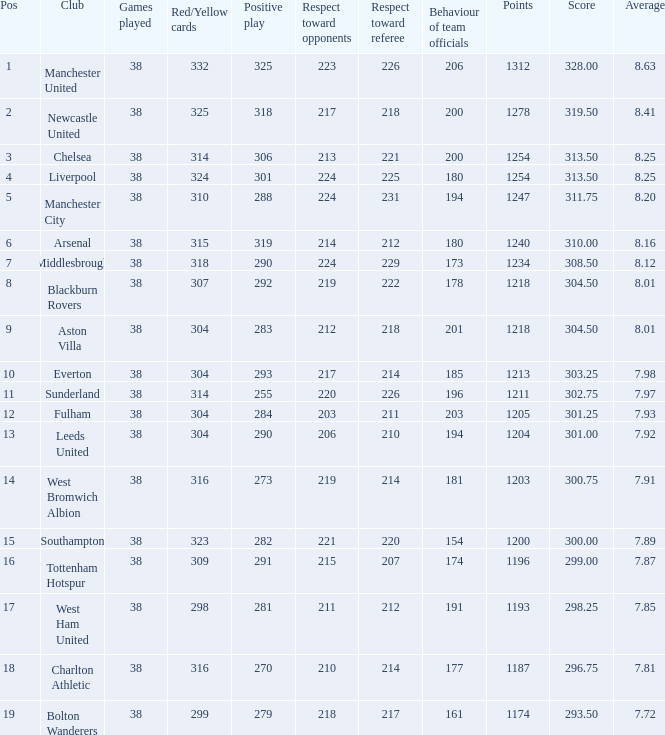Determine the most advantageous element for west bromwich albion club. 14.0. 